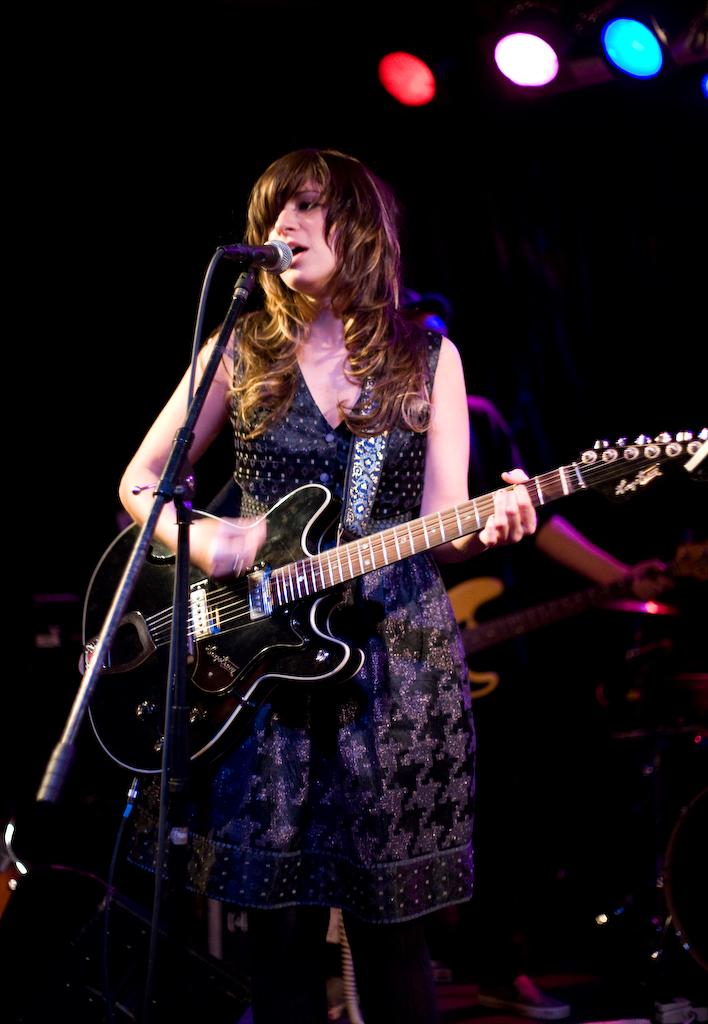Who is the main subject in the image? There is a lady in the image. What is the lady wearing? The lady is wearing a black frock. What is the lady doing in the image? The lady is playing a guitar. What object is in front of the lady? There is a microphone in front of the lady. Are there any other people in the image? Yes, there is another person in the image. What is the other person doing? The other person is playing a guitar. What type of knee injury is the lady experiencing in the image? There is no indication of a knee injury in the image; the lady is playing a guitar. 